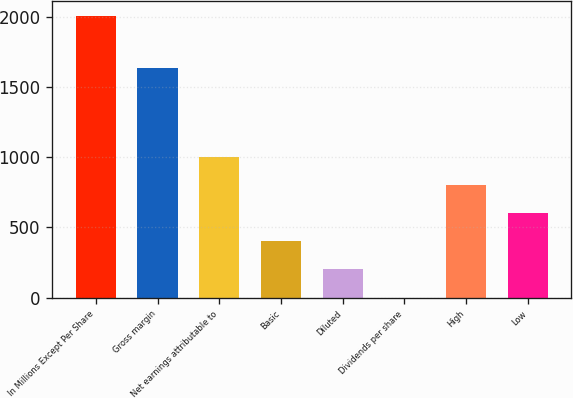Convert chart. <chart><loc_0><loc_0><loc_500><loc_500><bar_chart><fcel>In Millions Except Per Share<fcel>Gross margin<fcel>Net earnings attributable to<fcel>Basic<fcel>Diluted<fcel>Dividends per share<fcel>High<fcel>Low<nl><fcel>2011<fcel>1634<fcel>1005.63<fcel>402.42<fcel>201.35<fcel>0.28<fcel>804.56<fcel>603.49<nl></chart> 